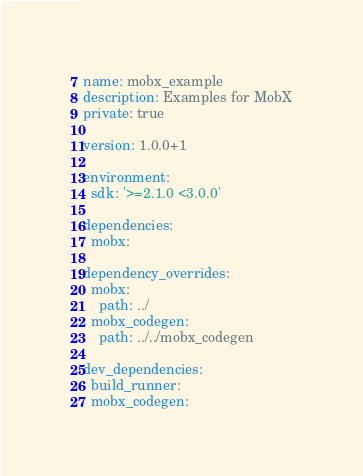Convert code to text. <code><loc_0><loc_0><loc_500><loc_500><_YAML_>name: mobx_example
description: Examples for MobX
private: true

version: 1.0.0+1

environment:
  sdk: '>=2.1.0 <3.0.0'

dependencies:
  mobx:

dependency_overrides:
  mobx:
    path: ../
  mobx_codegen:
    path: ../../mobx_codegen

dev_dependencies:
  build_runner:
  mobx_codegen:
</code> 